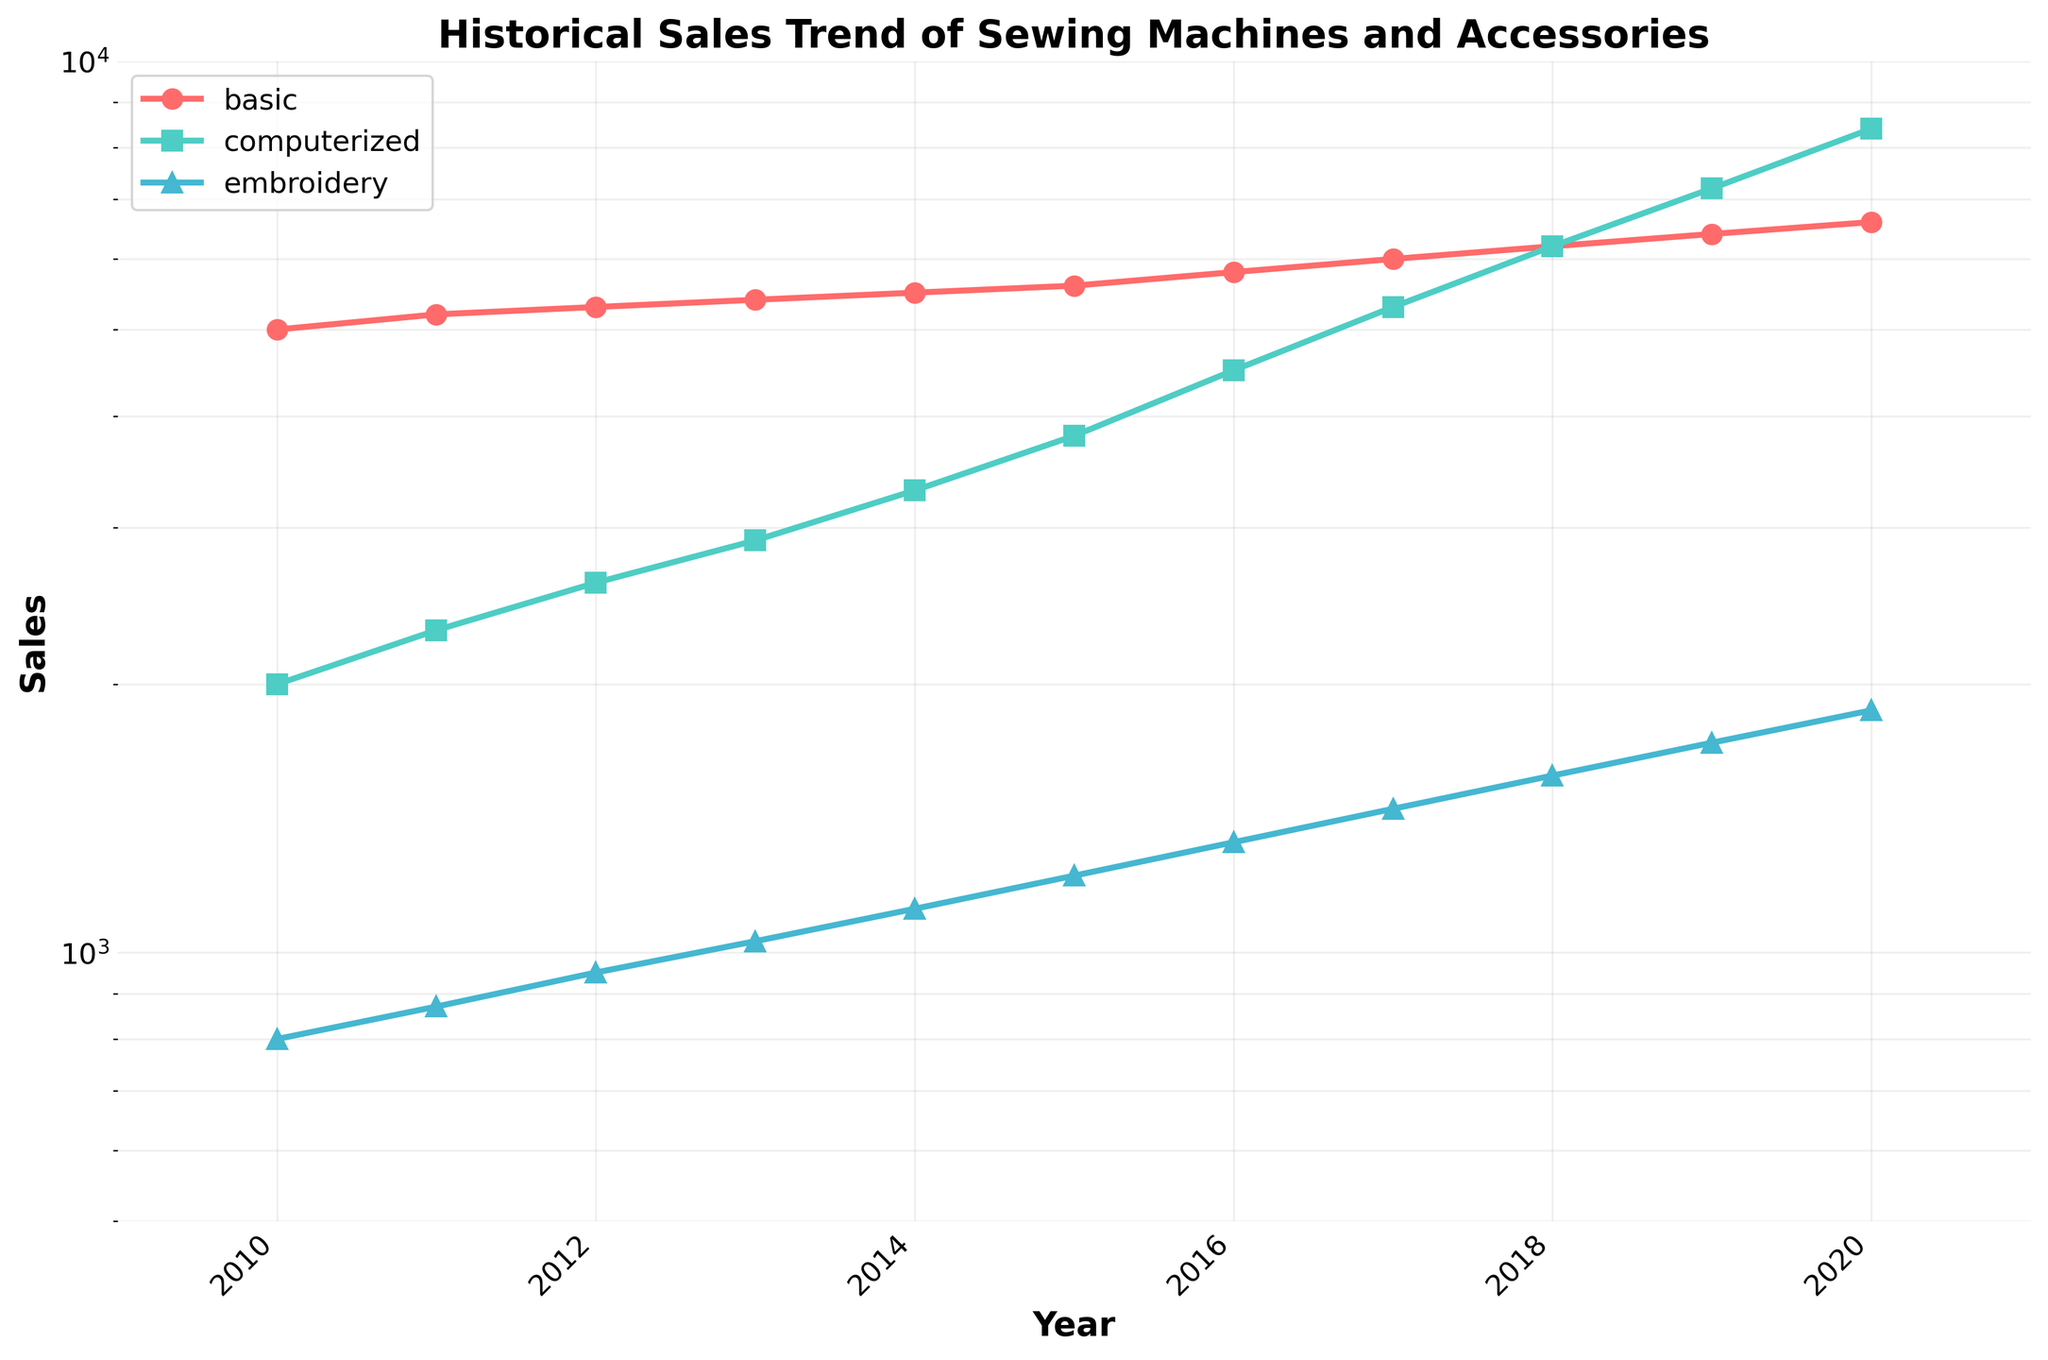What is the title of the figure? The title is usually found at the top of the figure.
Answer: Historical Sales Trend of Sewing Machines and Accessories Which category has the highest sales in 2020? Look at the data points for the year 2020 and compare the values for each category.
Answer: Computerized Which two categories have the closest sales values in 2018? Check the sales values for each category in 2018 and identify the two that are closest in value.
Answer: Basic and Computerized How do the sales trends of basic and computerized models compare over the years? Observe the line plots of both categories to determine if they are increasing, decreasing, or showing any other trends relative to each other.
Answer: Both are increasing, but computerized is increasing faster What is the range of sales values for embroidery machines from 2010 to 2020? Identify the minimum and maximum sales values for embroidery machines within the given years and calculate the difference.
Answer: 800 to 1870 What's the average sales value for basic machines from 2010 to 2020? Sum up all sales values for basic machines from 2010 to 2020 and divide by the number of years.
Answer: (5000 + 5200 + 5300 + 5400 + 5500 + 5600 + 5800 + 6000 + 6200 + 6400 + 6600)/11 = 5645 Which year did computerized machines see their highest growth in sales, and by how much? Compare the year-over-year sales values to determine the largest increase, focusing on computerized models.
Answer: 2019 to 2020, increase of 1200 How does the sales growth of embroidery machines over the decade compare to that of computerized machines? Calculate the difference in sales from 2010 to 2020 for both embroidery and computerized machines.
Answer: Embroidery increased by 1070, Computerized increased by 6400 Are there any noticeable patterns in the data that might indicate a key turning point for any category? Look for sharp increases, decreases, or changes in the growth rate in any of the lines.
Answer: Computerized machines saw significant growth starting from 2014 What can you say about the overall trend of the sales for all three categories from 2010 to 2020? Assess whether the sales for each category are increasing, decreasing, or stagnating over the entire period.
Answer: All three categories show an increasing trend, with computerized machines having the steepest increase 